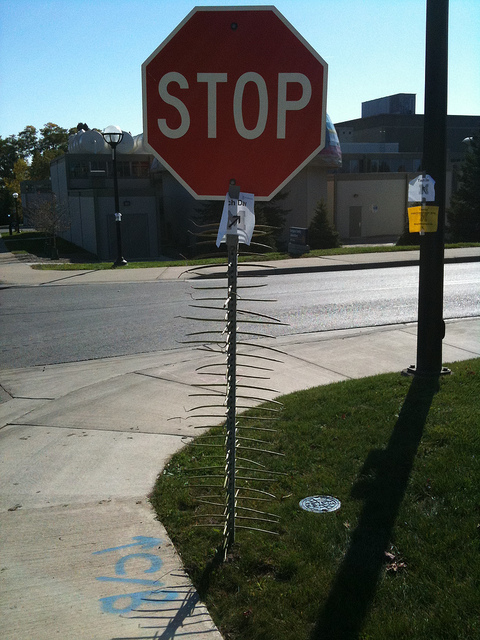<image>What does the blue writing say? I am not sure what the blue writing says. It could say 'tc b', 'c b' or 'arrow c b'. What does the blue writing say? I don't know what the blue writing says. It can be either 'tc b' or 'c b'. 